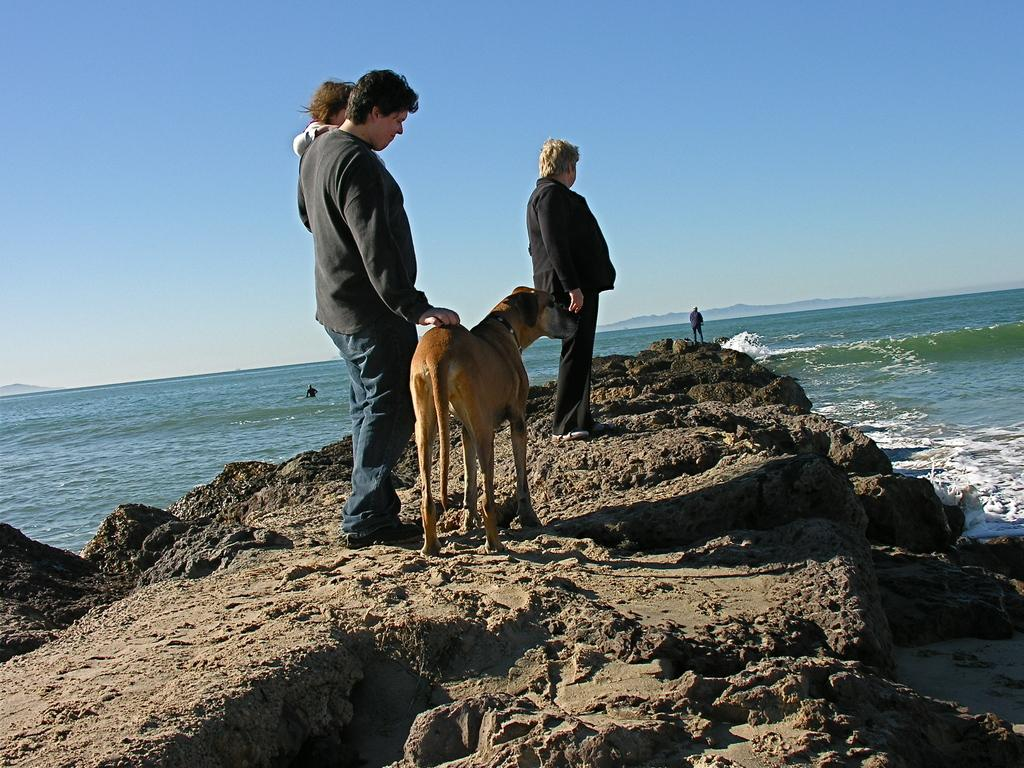Who or what can be seen in the image? There are people and a dog in the image. What are the people and dog standing on? They are standing on rocks. Where are these rocks located? The rocks are near the sea. What is the purpose of the vein in the image? There is no vein present in the image. Who is the dog's friend in the image? The provided facts do not mention any specific friend for the dog in the image. 